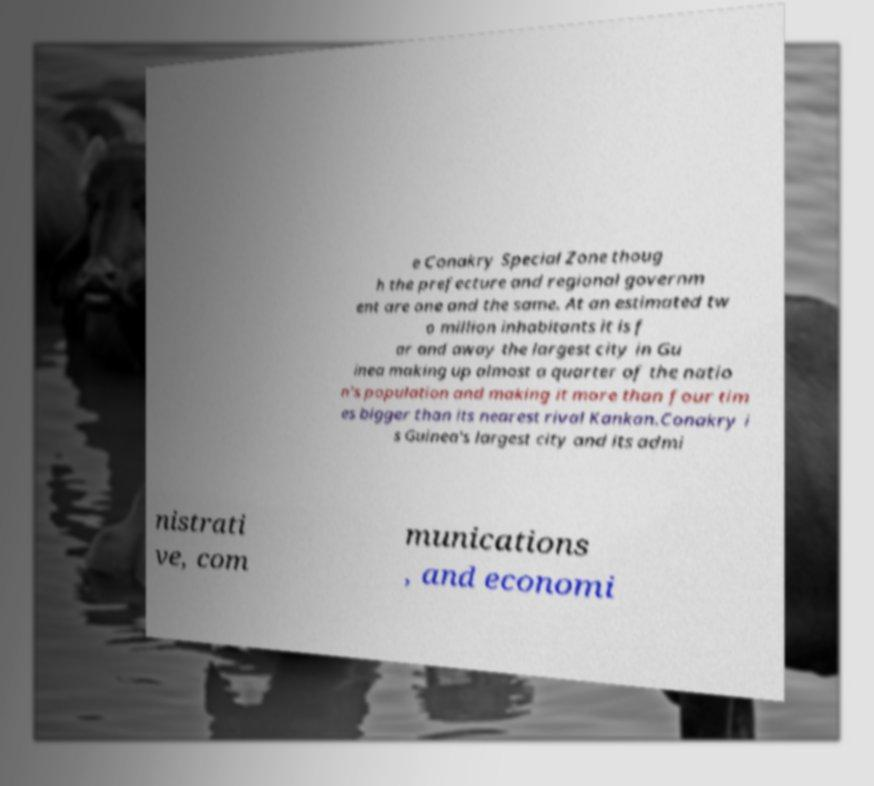For documentation purposes, I need the text within this image transcribed. Could you provide that? e Conakry Special Zone thoug h the prefecture and regional governm ent are one and the same. At an estimated tw o million inhabitants it is f ar and away the largest city in Gu inea making up almost a quarter of the natio n's population and making it more than four tim es bigger than its nearest rival Kankan.Conakry i s Guinea's largest city and its admi nistrati ve, com munications , and economi 